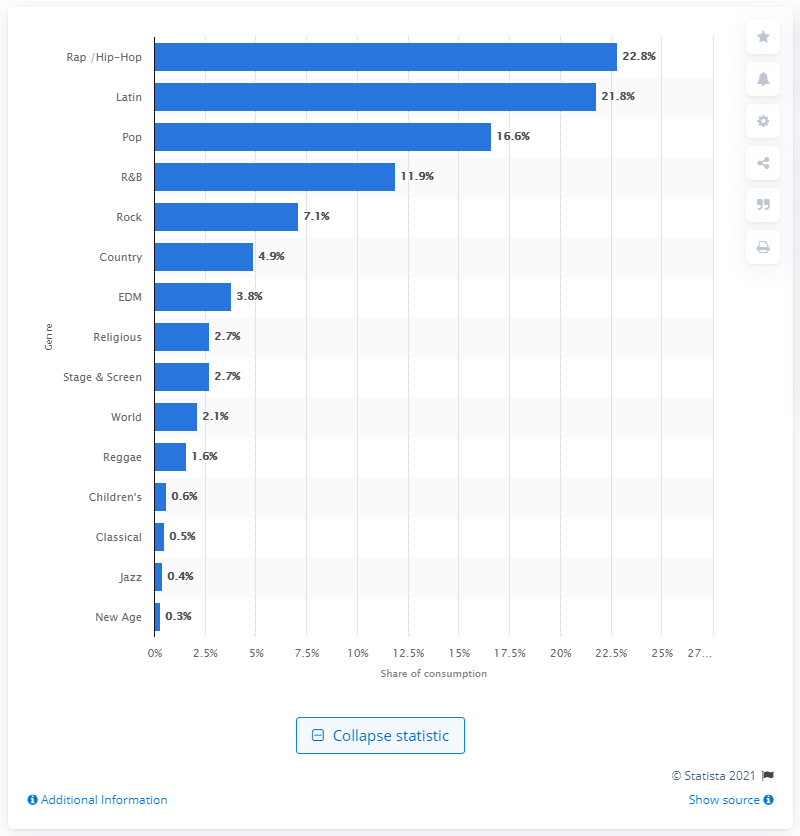Specify some key components in this picture. In 2018, 4.9% of all video streams were country video streams. 